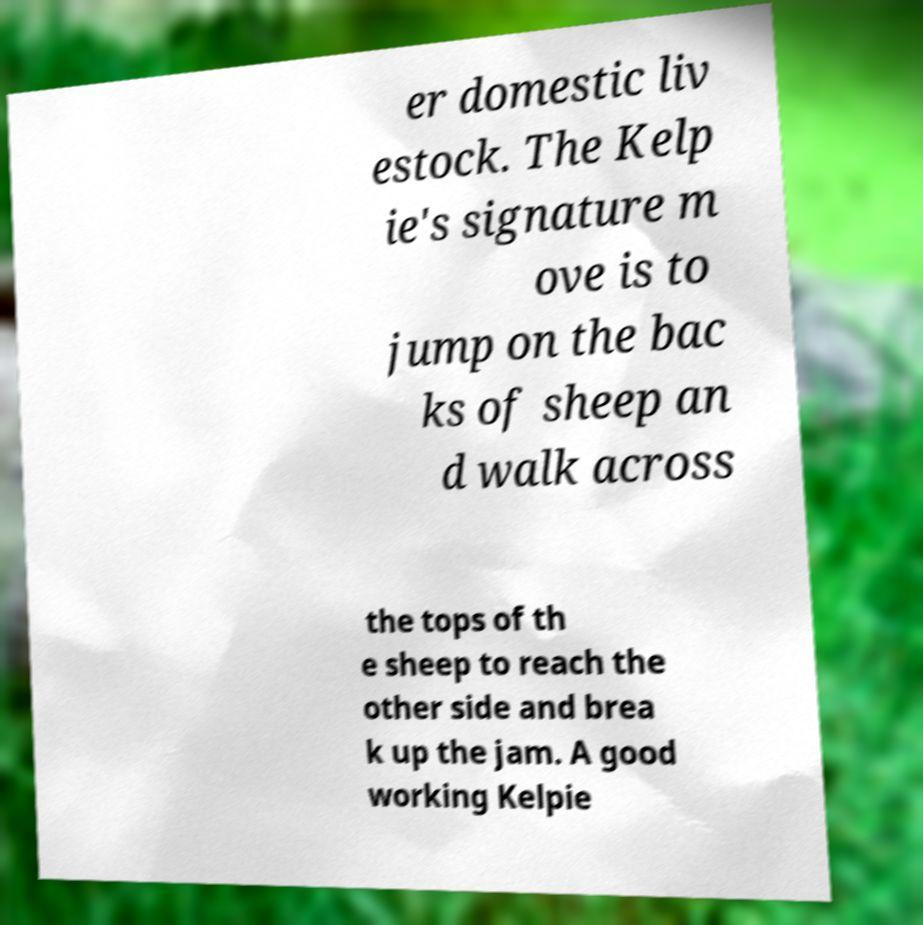What messages or text are displayed in this image? I need them in a readable, typed format. er domestic liv estock. The Kelp ie's signature m ove is to jump on the bac ks of sheep an d walk across the tops of th e sheep to reach the other side and brea k up the jam. A good working Kelpie 